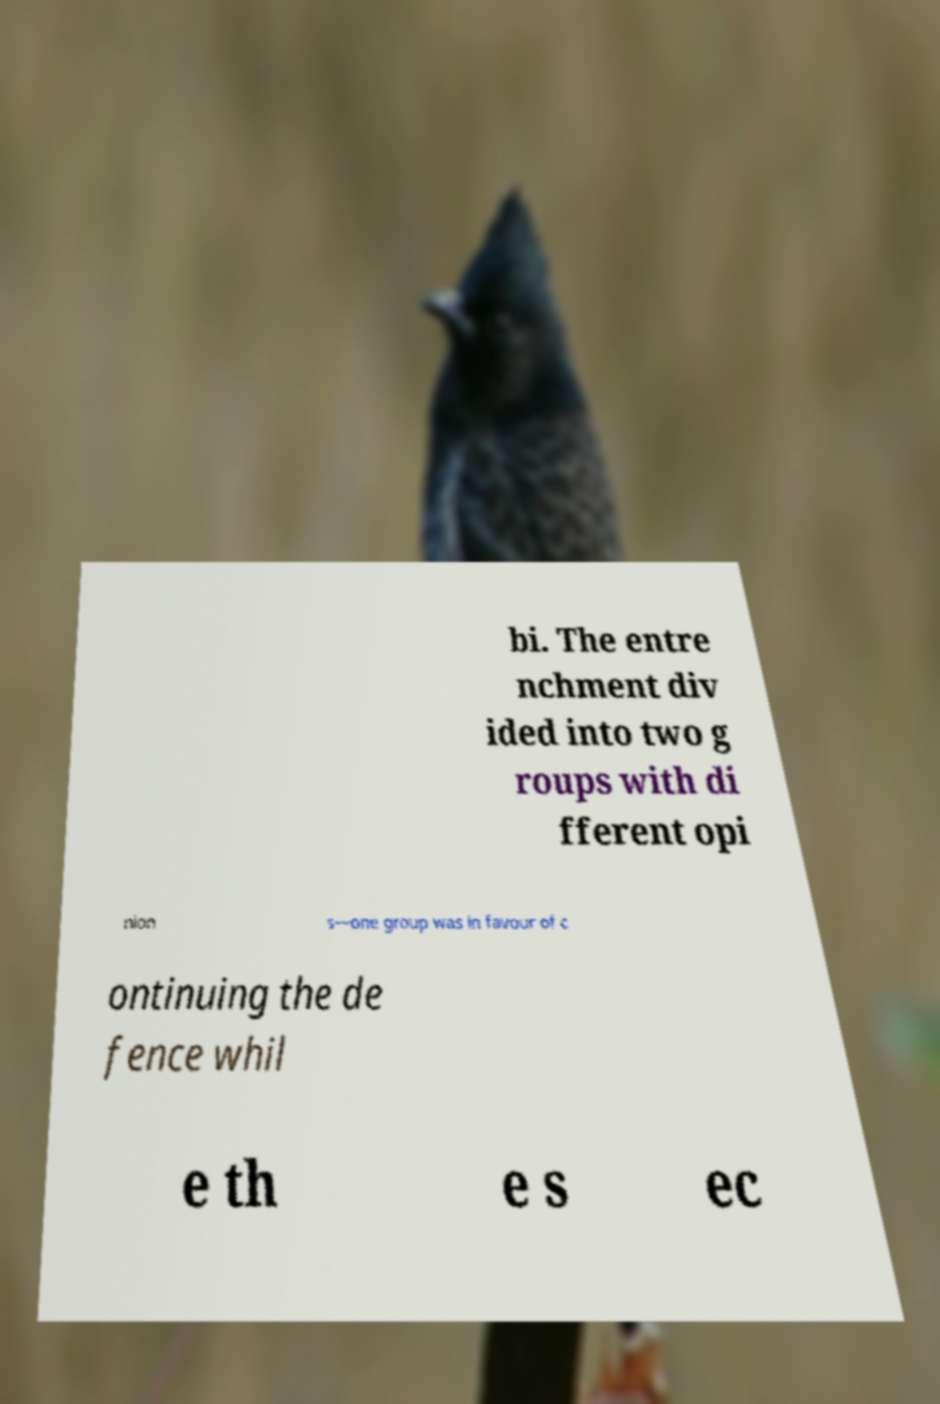Can you accurately transcribe the text from the provided image for me? bi. The entre nchment div ided into two g roups with di fferent opi nion s—one group was in favour of c ontinuing the de fence whil e th e s ec 